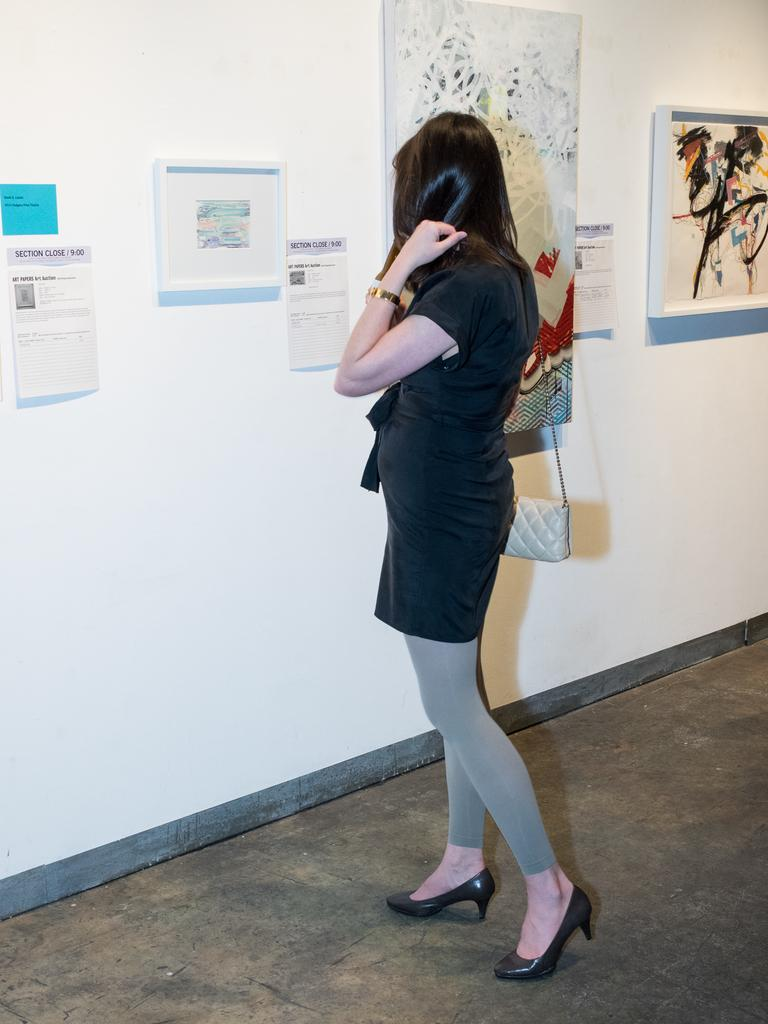What is the woman doing in the image? The woman is standing in the image. What is the woman holding or carrying in the image? The woman is carrying a purse. What can be seen on the wall in the image? There are papers and photo frames on the wall in the image. What type of veil is covering the board in the image? There is no board or veil present in the image. 